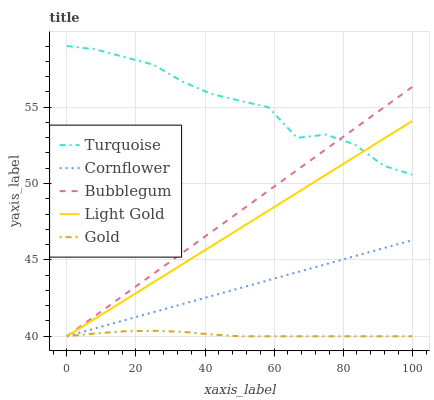Does Gold have the minimum area under the curve?
Answer yes or no. Yes. Does Turquoise have the maximum area under the curve?
Answer yes or no. Yes. Does Light Gold have the minimum area under the curve?
Answer yes or no. No. Does Light Gold have the maximum area under the curve?
Answer yes or no. No. Is Light Gold the smoothest?
Answer yes or no. Yes. Is Turquoise the roughest?
Answer yes or no. Yes. Is Turquoise the smoothest?
Answer yes or no. No. Is Light Gold the roughest?
Answer yes or no. No. Does Turquoise have the lowest value?
Answer yes or no. No. Does Turquoise have the highest value?
Answer yes or no. Yes. Does Light Gold have the highest value?
Answer yes or no. No. Is Cornflower less than Turquoise?
Answer yes or no. Yes. Is Turquoise greater than Cornflower?
Answer yes or no. Yes. Does Cornflower intersect Light Gold?
Answer yes or no. Yes. Is Cornflower less than Light Gold?
Answer yes or no. No. Is Cornflower greater than Light Gold?
Answer yes or no. No. Does Cornflower intersect Turquoise?
Answer yes or no. No. 